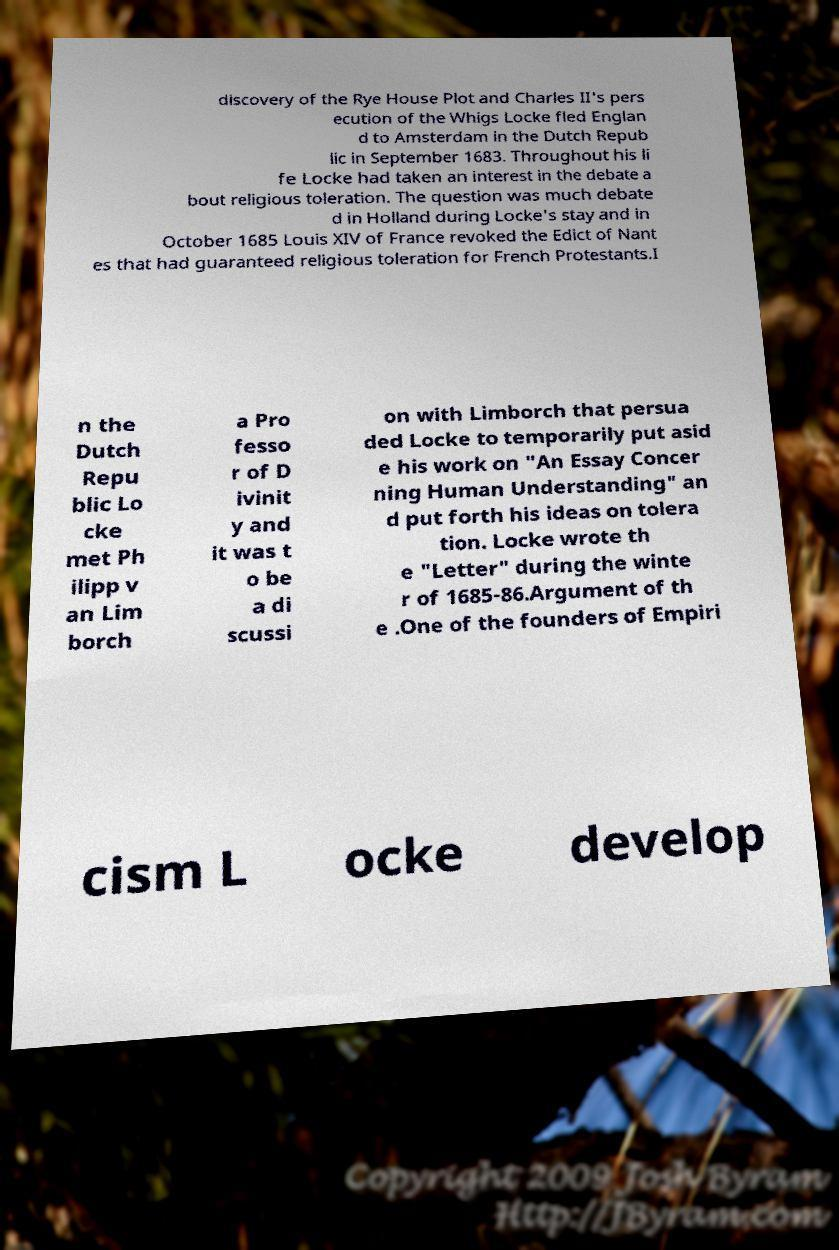Could you extract and type out the text from this image? discovery of the Rye House Plot and Charles II's pers ecution of the Whigs Locke fled Englan d to Amsterdam in the Dutch Repub lic in September 1683. Throughout his li fe Locke had taken an interest in the debate a bout religious toleration. The question was much debate d in Holland during Locke's stay and in October 1685 Louis XIV of France revoked the Edict of Nant es that had guaranteed religious toleration for French Protestants.I n the Dutch Repu blic Lo cke met Ph ilipp v an Lim borch a Pro fesso r of D ivinit y and it was t o be a di scussi on with Limborch that persua ded Locke to temporarily put asid e his work on "An Essay Concer ning Human Understanding" an d put forth his ideas on tolera tion. Locke wrote th e "Letter" during the winte r of 1685-86.Argument of th e .One of the founders of Empiri cism L ocke develop 